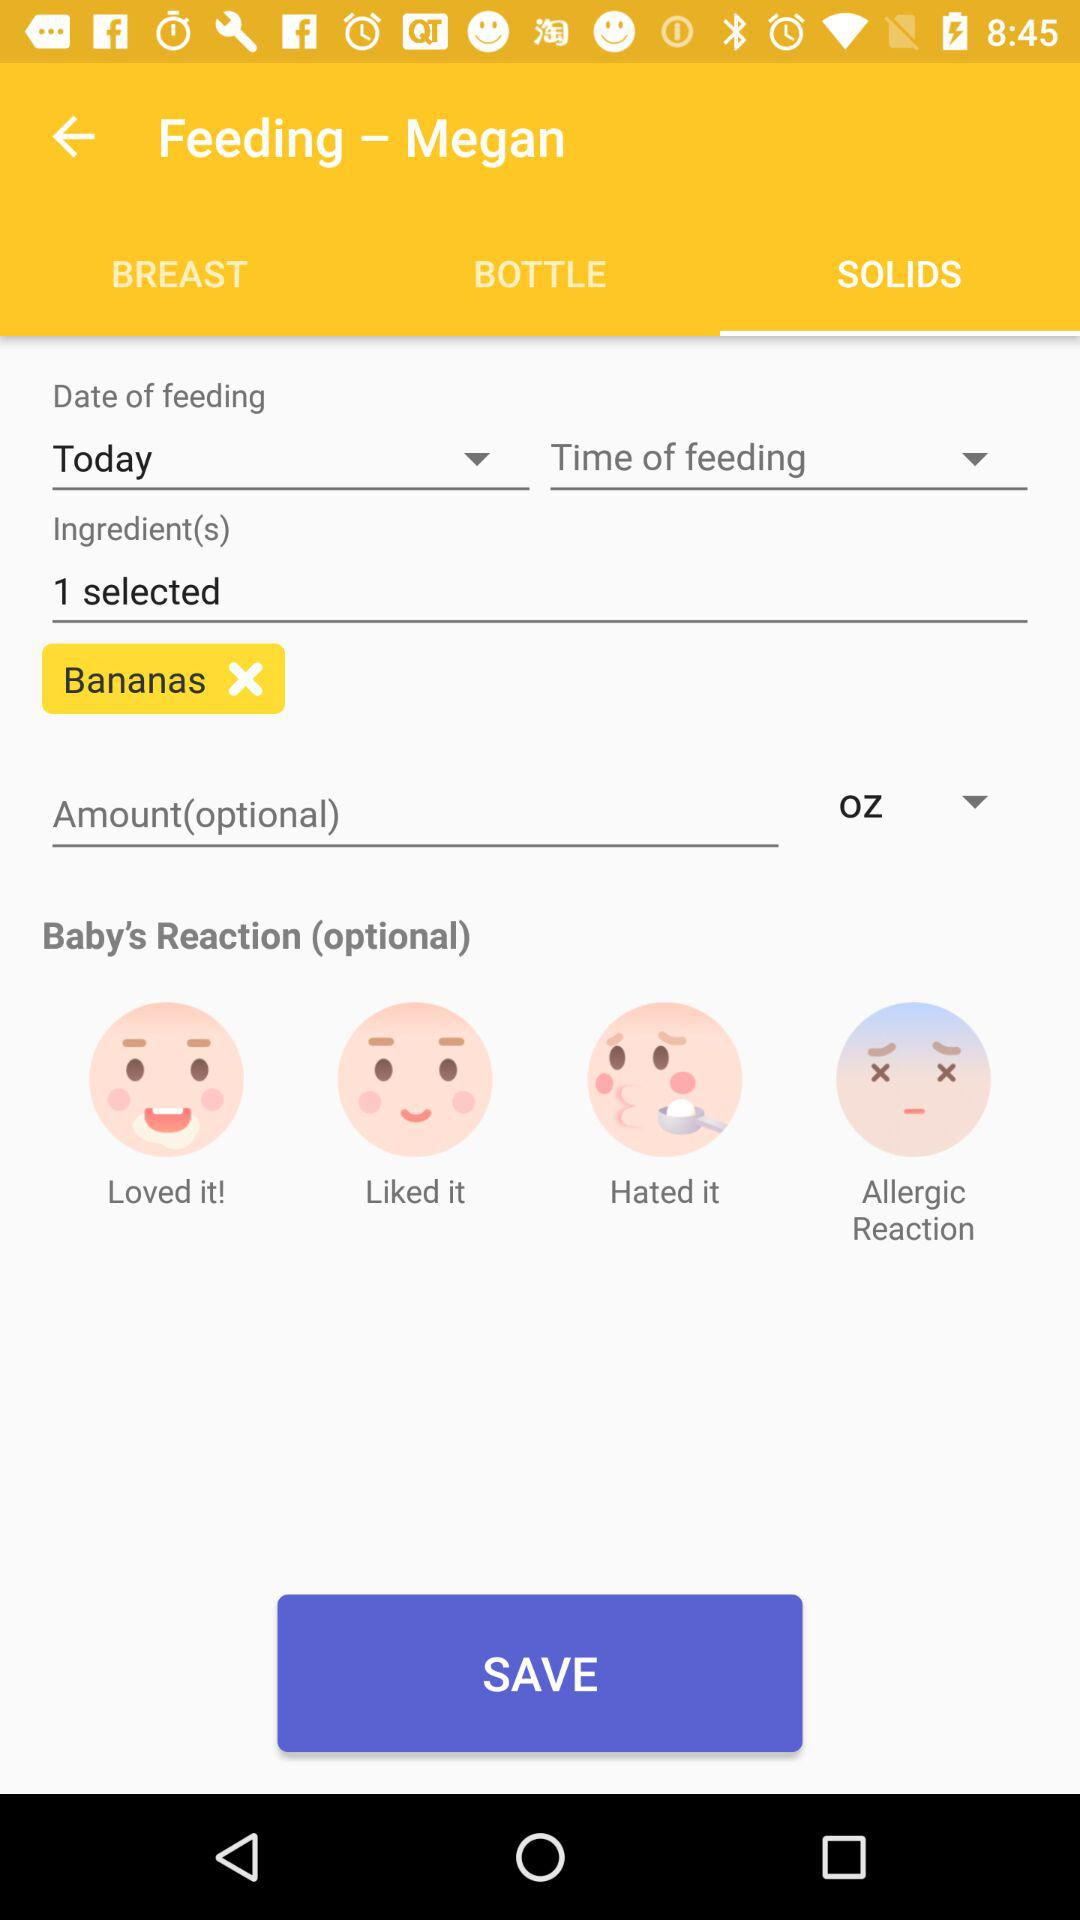How many reaction options are there?
Answer the question using a single word or phrase. 4 